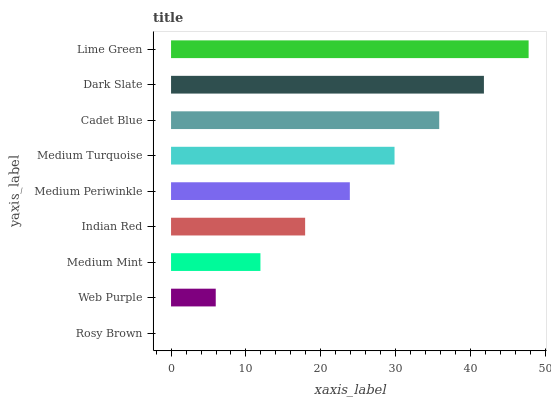Is Rosy Brown the minimum?
Answer yes or no. Yes. Is Lime Green the maximum?
Answer yes or no. Yes. Is Web Purple the minimum?
Answer yes or no. No. Is Web Purple the maximum?
Answer yes or no. No. Is Web Purple greater than Rosy Brown?
Answer yes or no. Yes. Is Rosy Brown less than Web Purple?
Answer yes or no. Yes. Is Rosy Brown greater than Web Purple?
Answer yes or no. No. Is Web Purple less than Rosy Brown?
Answer yes or no. No. Is Medium Periwinkle the high median?
Answer yes or no. Yes. Is Medium Periwinkle the low median?
Answer yes or no. Yes. Is Cadet Blue the high median?
Answer yes or no. No. Is Medium Mint the low median?
Answer yes or no. No. 